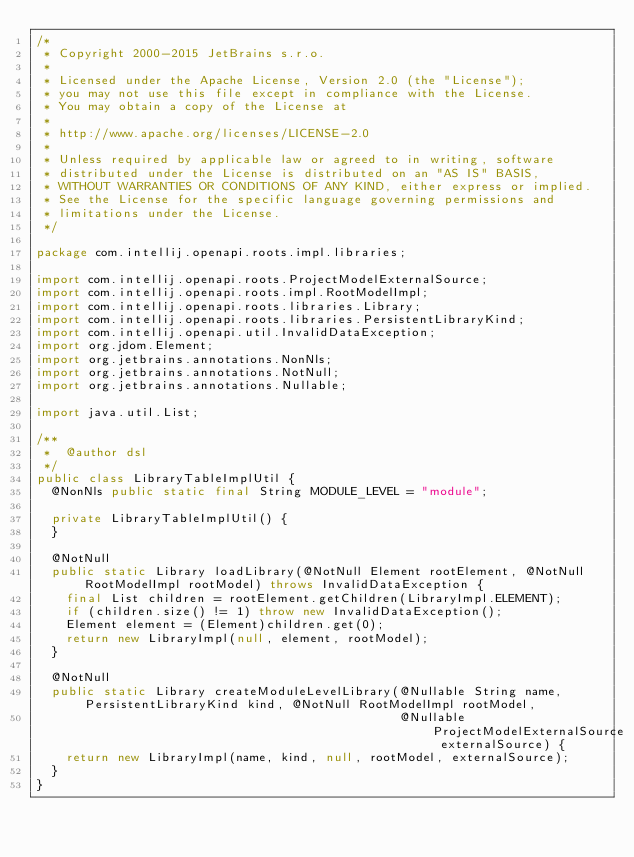Convert code to text. <code><loc_0><loc_0><loc_500><loc_500><_Java_>/*
 * Copyright 2000-2015 JetBrains s.r.o.
 *
 * Licensed under the Apache License, Version 2.0 (the "License");
 * you may not use this file except in compliance with the License.
 * You may obtain a copy of the License at
 *
 * http://www.apache.org/licenses/LICENSE-2.0
 *
 * Unless required by applicable law or agreed to in writing, software
 * distributed under the License is distributed on an "AS IS" BASIS,
 * WITHOUT WARRANTIES OR CONDITIONS OF ANY KIND, either express or implied.
 * See the License for the specific language governing permissions and
 * limitations under the License.
 */

package com.intellij.openapi.roots.impl.libraries;

import com.intellij.openapi.roots.ProjectModelExternalSource;
import com.intellij.openapi.roots.impl.RootModelImpl;
import com.intellij.openapi.roots.libraries.Library;
import com.intellij.openapi.roots.libraries.PersistentLibraryKind;
import com.intellij.openapi.util.InvalidDataException;
import org.jdom.Element;
import org.jetbrains.annotations.NonNls;
import org.jetbrains.annotations.NotNull;
import org.jetbrains.annotations.Nullable;

import java.util.List;

/**
 *  @author dsl
 */
public class LibraryTableImplUtil {
  @NonNls public static final String MODULE_LEVEL = "module";

  private LibraryTableImplUtil() {
  }

  @NotNull
  public static Library loadLibrary(@NotNull Element rootElement, @NotNull RootModelImpl rootModel) throws InvalidDataException {
    final List children = rootElement.getChildren(LibraryImpl.ELEMENT);
    if (children.size() != 1) throw new InvalidDataException();
    Element element = (Element)children.get(0);
    return new LibraryImpl(null, element, rootModel);
  }

  @NotNull
  public static Library createModuleLevelLibrary(@Nullable String name, PersistentLibraryKind kind, @NotNull RootModelImpl rootModel,
                                                 @Nullable ProjectModelExternalSource externalSource) {
    return new LibraryImpl(name, kind, null, rootModel, externalSource);
  }
}
</code> 